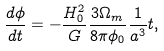Convert formula to latex. <formula><loc_0><loc_0><loc_500><loc_500>\frac { d \phi } { d t } = - \frac { H _ { 0 } ^ { 2 } } { G } \frac { 3 \Omega _ { m } } { 8 \pi \phi _ { 0 } } \frac { 1 } { a ^ { 3 } } t ,</formula> 